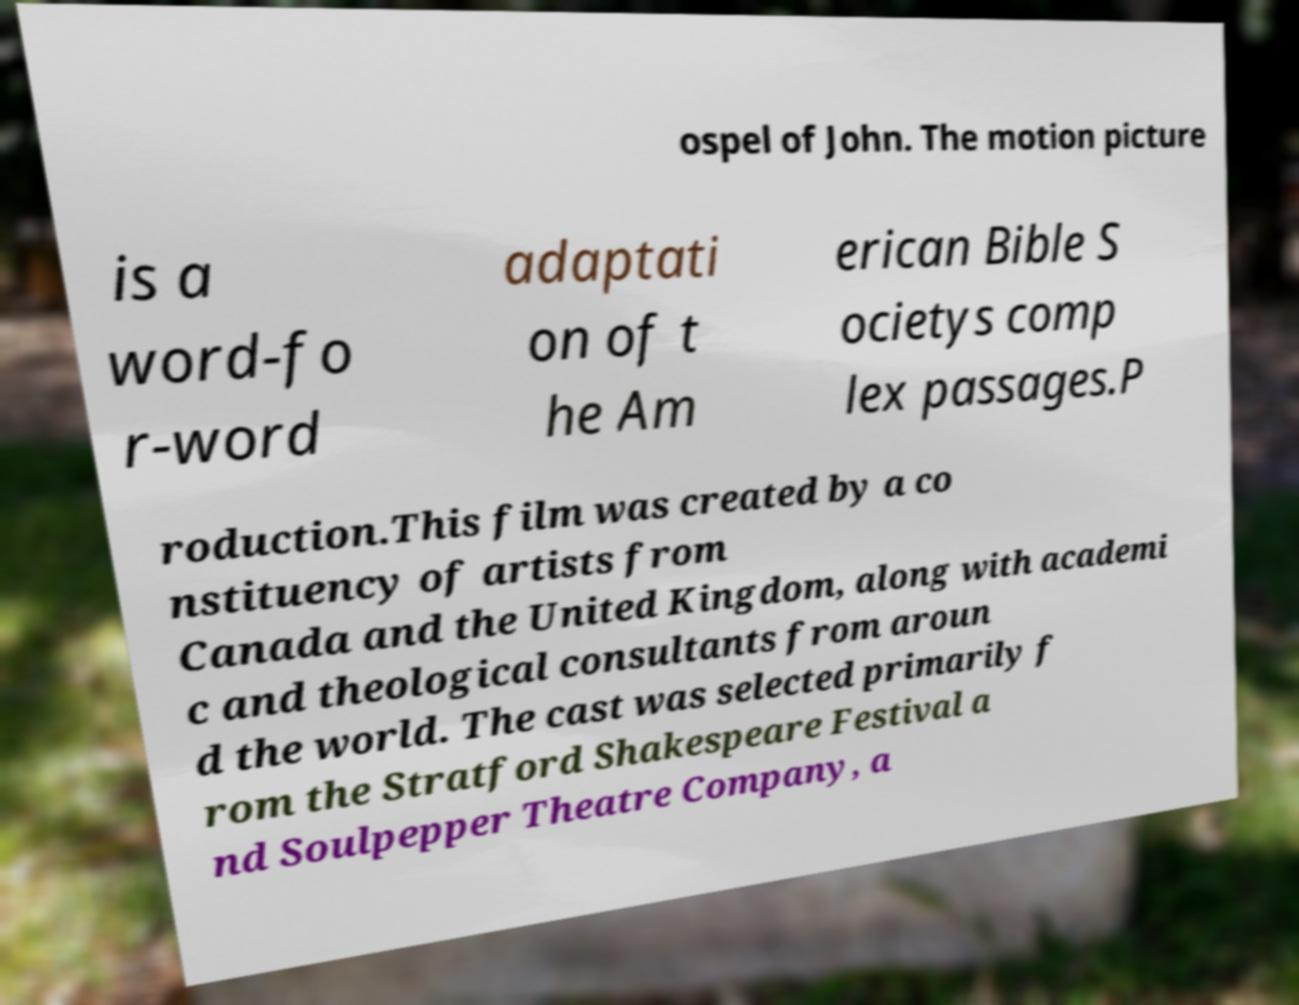Can you accurately transcribe the text from the provided image for me? ospel of John. The motion picture is a word-fo r-word adaptati on of t he Am erican Bible S ocietys comp lex passages.P roduction.This film was created by a co nstituency of artists from Canada and the United Kingdom, along with academi c and theological consultants from aroun d the world. The cast was selected primarily f rom the Stratford Shakespeare Festival a nd Soulpepper Theatre Company, a 